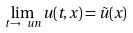Convert formula to latex. <formula><loc_0><loc_0><loc_500><loc_500>\lim _ { t \rightarrow \ u n } u ( t , x ) = \tilde { u } ( x )</formula> 